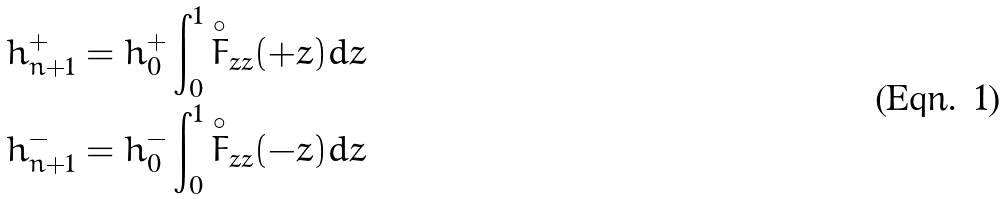Convert formula to latex. <formula><loc_0><loc_0><loc_500><loc_500>h ^ { + } _ { n + 1 } & = h ^ { + } _ { 0 } \int ^ { 1 } _ { 0 } \overset { \circ } { F } _ { z z } ( + z ) d z \\ h ^ { - } _ { n + 1 } & = h ^ { - } _ { 0 } \int ^ { 1 } _ { 0 } \overset { \circ } { F } _ { z z } ( - z ) d z</formula> 